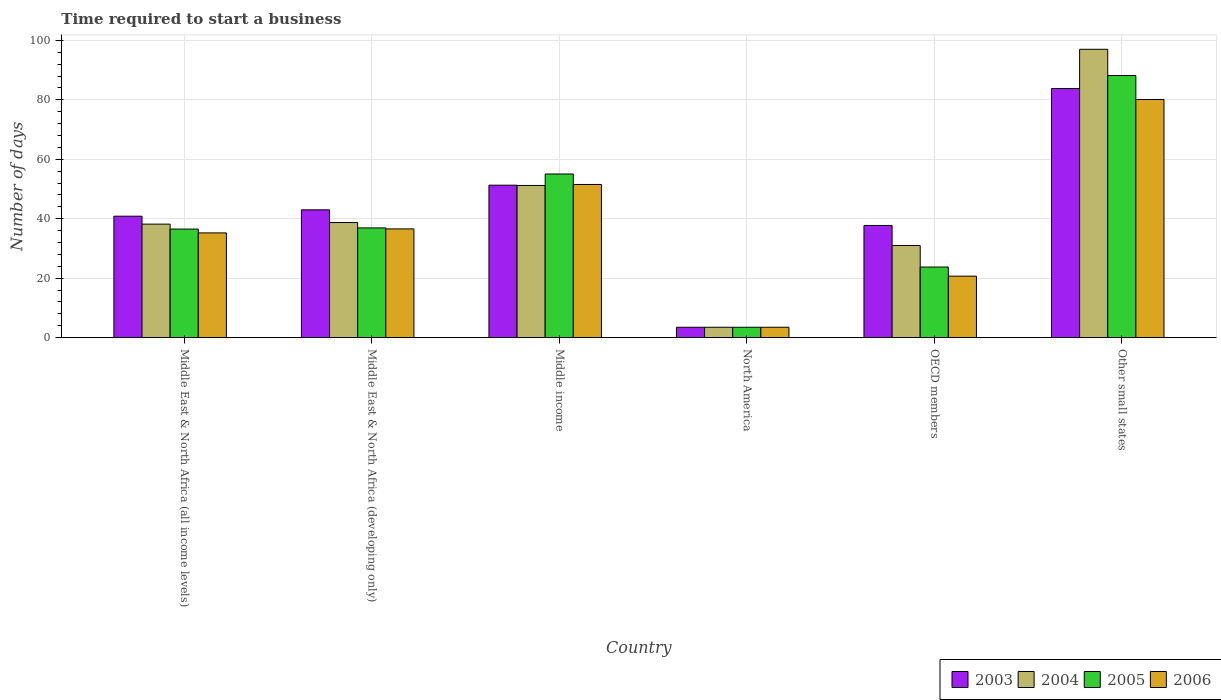How many different coloured bars are there?
Keep it short and to the point. 4. How many groups of bars are there?
Your response must be concise. 6. Are the number of bars per tick equal to the number of legend labels?
Offer a terse response. Yes. How many bars are there on the 4th tick from the left?
Offer a very short reply. 4. How many bars are there on the 3rd tick from the right?
Offer a very short reply. 4. What is the number of days required to start a business in 2004 in Middle East & North Africa (developing only)?
Give a very brief answer. 38.73. Across all countries, what is the maximum number of days required to start a business in 2003?
Keep it short and to the point. 83.8. In which country was the number of days required to start a business in 2005 maximum?
Offer a terse response. Other small states. What is the total number of days required to start a business in 2006 in the graph?
Offer a terse response. 227.65. What is the difference between the number of days required to start a business in 2005 in Middle East & North Africa (all income levels) and that in Middle East & North Africa (developing only)?
Offer a terse response. -0.39. What is the difference between the number of days required to start a business in 2006 in OECD members and the number of days required to start a business in 2003 in North America?
Keep it short and to the point. 17.19. What is the average number of days required to start a business in 2004 per country?
Provide a short and direct response. 43.27. What is the difference between the number of days required to start a business of/in 2006 and number of days required to start a business of/in 2005 in Middle East & North Africa (all income levels)?
Offer a terse response. -1.29. What is the ratio of the number of days required to start a business in 2003 in Middle East & North Africa (all income levels) to that in Middle income?
Make the answer very short. 0.8. Is the number of days required to start a business in 2003 in Middle East & North Africa (all income levels) less than that in Middle East & North Africa (developing only)?
Keep it short and to the point. Yes. What is the difference between the highest and the second highest number of days required to start a business in 2003?
Offer a very short reply. -32.51. What is the difference between the highest and the lowest number of days required to start a business in 2004?
Your answer should be compact. 93.5. In how many countries, is the number of days required to start a business in 2004 greater than the average number of days required to start a business in 2004 taken over all countries?
Make the answer very short. 2. Is it the case that in every country, the sum of the number of days required to start a business in 2006 and number of days required to start a business in 2004 is greater than the sum of number of days required to start a business in 2003 and number of days required to start a business in 2005?
Your answer should be very brief. No. What does the 3rd bar from the left in Middle East & North Africa (developing only) represents?
Offer a very short reply. 2005. What does the 2nd bar from the right in North America represents?
Make the answer very short. 2005. Are all the bars in the graph horizontal?
Offer a very short reply. No. How many countries are there in the graph?
Provide a short and direct response. 6. Where does the legend appear in the graph?
Offer a very short reply. Bottom right. What is the title of the graph?
Offer a terse response. Time required to start a business. Does "2014" appear as one of the legend labels in the graph?
Keep it short and to the point. No. What is the label or title of the Y-axis?
Your answer should be compact. Number of days. What is the Number of days of 2003 in Middle East & North Africa (all income levels)?
Your answer should be compact. 40.86. What is the Number of days of 2004 in Middle East & North Africa (all income levels)?
Your response must be concise. 38.19. What is the Number of days of 2005 in Middle East & North Africa (all income levels)?
Offer a terse response. 36.53. What is the Number of days of 2006 in Middle East & North Africa (all income levels)?
Make the answer very short. 35.24. What is the Number of days of 2004 in Middle East & North Africa (developing only)?
Ensure brevity in your answer.  38.73. What is the Number of days of 2005 in Middle East & North Africa (developing only)?
Offer a very short reply. 36.92. What is the Number of days in 2006 in Middle East & North Africa (developing only)?
Your answer should be compact. 36.58. What is the Number of days of 2003 in Middle income?
Keep it short and to the point. 51.29. What is the Number of days of 2004 in Middle income?
Ensure brevity in your answer.  51.19. What is the Number of days in 2005 in Middle income?
Provide a succinct answer. 55.06. What is the Number of days in 2006 in Middle income?
Your answer should be very brief. 51.53. What is the Number of days in 2003 in North America?
Your response must be concise. 3.5. What is the Number of days in 2005 in North America?
Make the answer very short. 3.5. What is the Number of days of 2003 in OECD members?
Your response must be concise. 37.74. What is the Number of days of 2004 in OECD members?
Make the answer very short. 31.02. What is the Number of days in 2005 in OECD members?
Ensure brevity in your answer.  23.75. What is the Number of days of 2006 in OECD members?
Ensure brevity in your answer.  20.69. What is the Number of days of 2003 in Other small states?
Your answer should be very brief. 83.8. What is the Number of days of 2004 in Other small states?
Your answer should be compact. 97. What is the Number of days in 2005 in Other small states?
Provide a short and direct response. 88.18. What is the Number of days of 2006 in Other small states?
Your answer should be very brief. 80.11. Across all countries, what is the maximum Number of days in 2003?
Provide a short and direct response. 83.8. Across all countries, what is the maximum Number of days of 2004?
Your response must be concise. 97. Across all countries, what is the maximum Number of days of 2005?
Offer a terse response. 88.18. Across all countries, what is the maximum Number of days of 2006?
Offer a terse response. 80.11. Across all countries, what is the minimum Number of days in 2004?
Provide a succinct answer. 3.5. What is the total Number of days in 2003 in the graph?
Provide a short and direct response. 260.18. What is the total Number of days of 2004 in the graph?
Make the answer very short. 259.63. What is the total Number of days in 2005 in the graph?
Your answer should be very brief. 243.93. What is the total Number of days in 2006 in the graph?
Your answer should be very brief. 227.65. What is the difference between the Number of days in 2003 in Middle East & North Africa (all income levels) and that in Middle East & North Africa (developing only)?
Provide a succinct answer. -2.14. What is the difference between the Number of days in 2004 in Middle East & North Africa (all income levels) and that in Middle East & North Africa (developing only)?
Offer a terse response. -0.54. What is the difference between the Number of days in 2005 in Middle East & North Africa (all income levels) and that in Middle East & North Africa (developing only)?
Your answer should be compact. -0.39. What is the difference between the Number of days of 2006 in Middle East & North Africa (all income levels) and that in Middle East & North Africa (developing only)?
Make the answer very short. -1.35. What is the difference between the Number of days of 2003 in Middle East & North Africa (all income levels) and that in Middle income?
Your answer should be very brief. -10.43. What is the difference between the Number of days in 2004 in Middle East & North Africa (all income levels) and that in Middle income?
Keep it short and to the point. -13.01. What is the difference between the Number of days of 2005 in Middle East & North Africa (all income levels) and that in Middle income?
Make the answer very short. -18.53. What is the difference between the Number of days in 2006 in Middle East & North Africa (all income levels) and that in Middle income?
Keep it short and to the point. -16.29. What is the difference between the Number of days of 2003 in Middle East & North Africa (all income levels) and that in North America?
Ensure brevity in your answer.  37.36. What is the difference between the Number of days in 2004 in Middle East & North Africa (all income levels) and that in North America?
Offer a terse response. 34.69. What is the difference between the Number of days in 2005 in Middle East & North Africa (all income levels) and that in North America?
Offer a terse response. 33.03. What is the difference between the Number of days of 2006 in Middle East & North Africa (all income levels) and that in North America?
Provide a short and direct response. 31.74. What is the difference between the Number of days in 2003 in Middle East & North Africa (all income levels) and that in OECD members?
Provide a succinct answer. 3.12. What is the difference between the Number of days of 2004 in Middle East & North Africa (all income levels) and that in OECD members?
Offer a terse response. 7.17. What is the difference between the Number of days in 2005 in Middle East & North Africa (all income levels) and that in OECD members?
Make the answer very short. 12.78. What is the difference between the Number of days in 2006 in Middle East & North Africa (all income levels) and that in OECD members?
Your answer should be very brief. 14.54. What is the difference between the Number of days in 2003 in Middle East & North Africa (all income levels) and that in Other small states?
Keep it short and to the point. -42.94. What is the difference between the Number of days of 2004 in Middle East & North Africa (all income levels) and that in Other small states?
Ensure brevity in your answer.  -58.81. What is the difference between the Number of days of 2005 in Middle East & North Africa (all income levels) and that in Other small states?
Provide a succinct answer. -51.65. What is the difference between the Number of days in 2006 in Middle East & North Africa (all income levels) and that in Other small states?
Provide a short and direct response. -44.88. What is the difference between the Number of days in 2003 in Middle East & North Africa (developing only) and that in Middle income?
Offer a terse response. -8.29. What is the difference between the Number of days in 2004 in Middle East & North Africa (developing only) and that in Middle income?
Ensure brevity in your answer.  -12.47. What is the difference between the Number of days of 2005 in Middle East & North Africa (developing only) and that in Middle income?
Offer a very short reply. -18.14. What is the difference between the Number of days of 2006 in Middle East & North Africa (developing only) and that in Middle income?
Your answer should be very brief. -14.94. What is the difference between the Number of days of 2003 in Middle East & North Africa (developing only) and that in North America?
Make the answer very short. 39.5. What is the difference between the Number of days in 2004 in Middle East & North Africa (developing only) and that in North America?
Offer a very short reply. 35.23. What is the difference between the Number of days of 2005 in Middle East & North Africa (developing only) and that in North America?
Keep it short and to the point. 33.42. What is the difference between the Number of days of 2006 in Middle East & North Africa (developing only) and that in North America?
Keep it short and to the point. 33.08. What is the difference between the Number of days in 2003 in Middle East & North Africa (developing only) and that in OECD members?
Provide a short and direct response. 5.26. What is the difference between the Number of days in 2004 in Middle East & North Africa (developing only) and that in OECD members?
Provide a succinct answer. 7.71. What is the difference between the Number of days of 2005 in Middle East & North Africa (developing only) and that in OECD members?
Offer a terse response. 13.17. What is the difference between the Number of days of 2006 in Middle East & North Africa (developing only) and that in OECD members?
Make the answer very short. 15.89. What is the difference between the Number of days in 2003 in Middle East & North Africa (developing only) and that in Other small states?
Provide a short and direct response. -40.8. What is the difference between the Number of days of 2004 in Middle East & North Africa (developing only) and that in Other small states?
Offer a terse response. -58.27. What is the difference between the Number of days of 2005 in Middle East & North Africa (developing only) and that in Other small states?
Offer a terse response. -51.26. What is the difference between the Number of days in 2006 in Middle East & North Africa (developing only) and that in Other small states?
Your answer should be very brief. -43.53. What is the difference between the Number of days in 2003 in Middle income and that in North America?
Your response must be concise. 47.79. What is the difference between the Number of days of 2004 in Middle income and that in North America?
Provide a short and direct response. 47.69. What is the difference between the Number of days of 2005 in Middle income and that in North America?
Provide a succinct answer. 51.56. What is the difference between the Number of days of 2006 in Middle income and that in North America?
Your answer should be very brief. 48.03. What is the difference between the Number of days of 2003 in Middle income and that in OECD members?
Ensure brevity in your answer.  13.54. What is the difference between the Number of days in 2004 in Middle income and that in OECD members?
Ensure brevity in your answer.  20.18. What is the difference between the Number of days of 2005 in Middle income and that in OECD members?
Provide a succinct answer. 31.31. What is the difference between the Number of days in 2006 in Middle income and that in OECD members?
Your answer should be compact. 30.83. What is the difference between the Number of days in 2003 in Middle income and that in Other small states?
Ensure brevity in your answer.  -32.51. What is the difference between the Number of days in 2004 in Middle income and that in Other small states?
Offer a very short reply. -45.81. What is the difference between the Number of days of 2005 in Middle income and that in Other small states?
Ensure brevity in your answer.  -33.12. What is the difference between the Number of days in 2006 in Middle income and that in Other small states?
Your answer should be compact. -28.58. What is the difference between the Number of days of 2003 in North America and that in OECD members?
Give a very brief answer. -34.24. What is the difference between the Number of days in 2004 in North America and that in OECD members?
Make the answer very short. -27.52. What is the difference between the Number of days in 2005 in North America and that in OECD members?
Your response must be concise. -20.25. What is the difference between the Number of days in 2006 in North America and that in OECD members?
Your answer should be compact. -17.19. What is the difference between the Number of days of 2003 in North America and that in Other small states?
Keep it short and to the point. -80.3. What is the difference between the Number of days of 2004 in North America and that in Other small states?
Provide a succinct answer. -93.5. What is the difference between the Number of days of 2005 in North America and that in Other small states?
Ensure brevity in your answer.  -84.68. What is the difference between the Number of days in 2006 in North America and that in Other small states?
Provide a succinct answer. -76.61. What is the difference between the Number of days in 2003 in OECD members and that in Other small states?
Offer a very short reply. -46.06. What is the difference between the Number of days of 2004 in OECD members and that in Other small states?
Provide a short and direct response. -65.98. What is the difference between the Number of days in 2005 in OECD members and that in Other small states?
Make the answer very short. -64.43. What is the difference between the Number of days in 2006 in OECD members and that in Other small states?
Give a very brief answer. -59.42. What is the difference between the Number of days of 2003 in Middle East & North Africa (all income levels) and the Number of days of 2004 in Middle East & North Africa (developing only)?
Keep it short and to the point. 2.13. What is the difference between the Number of days of 2003 in Middle East & North Africa (all income levels) and the Number of days of 2005 in Middle East & North Africa (developing only)?
Your response must be concise. 3.94. What is the difference between the Number of days in 2003 in Middle East & North Africa (all income levels) and the Number of days in 2006 in Middle East & North Africa (developing only)?
Ensure brevity in your answer.  4.27. What is the difference between the Number of days in 2004 in Middle East & North Africa (all income levels) and the Number of days in 2005 in Middle East & North Africa (developing only)?
Give a very brief answer. 1.27. What is the difference between the Number of days in 2004 in Middle East & North Africa (all income levels) and the Number of days in 2006 in Middle East & North Africa (developing only)?
Ensure brevity in your answer.  1.6. What is the difference between the Number of days of 2005 in Middle East & North Africa (all income levels) and the Number of days of 2006 in Middle East & North Africa (developing only)?
Provide a short and direct response. -0.05. What is the difference between the Number of days in 2003 in Middle East & North Africa (all income levels) and the Number of days in 2004 in Middle income?
Give a very brief answer. -10.34. What is the difference between the Number of days of 2003 in Middle East & North Africa (all income levels) and the Number of days of 2005 in Middle income?
Ensure brevity in your answer.  -14.2. What is the difference between the Number of days of 2003 in Middle East & North Africa (all income levels) and the Number of days of 2006 in Middle income?
Your response must be concise. -10.67. What is the difference between the Number of days of 2004 in Middle East & North Africa (all income levels) and the Number of days of 2005 in Middle income?
Provide a succinct answer. -16.87. What is the difference between the Number of days of 2004 in Middle East & North Africa (all income levels) and the Number of days of 2006 in Middle income?
Give a very brief answer. -13.34. What is the difference between the Number of days of 2005 in Middle East & North Africa (all income levels) and the Number of days of 2006 in Middle income?
Ensure brevity in your answer.  -15. What is the difference between the Number of days in 2003 in Middle East & North Africa (all income levels) and the Number of days in 2004 in North America?
Keep it short and to the point. 37.36. What is the difference between the Number of days of 2003 in Middle East & North Africa (all income levels) and the Number of days of 2005 in North America?
Provide a succinct answer. 37.36. What is the difference between the Number of days of 2003 in Middle East & North Africa (all income levels) and the Number of days of 2006 in North America?
Provide a succinct answer. 37.36. What is the difference between the Number of days in 2004 in Middle East & North Africa (all income levels) and the Number of days in 2005 in North America?
Make the answer very short. 34.69. What is the difference between the Number of days in 2004 in Middle East & North Africa (all income levels) and the Number of days in 2006 in North America?
Keep it short and to the point. 34.69. What is the difference between the Number of days of 2005 in Middle East & North Africa (all income levels) and the Number of days of 2006 in North America?
Your answer should be very brief. 33.03. What is the difference between the Number of days in 2003 in Middle East & North Africa (all income levels) and the Number of days in 2004 in OECD members?
Ensure brevity in your answer.  9.84. What is the difference between the Number of days in 2003 in Middle East & North Africa (all income levels) and the Number of days in 2005 in OECD members?
Offer a very short reply. 17.11. What is the difference between the Number of days in 2003 in Middle East & North Africa (all income levels) and the Number of days in 2006 in OECD members?
Offer a terse response. 20.16. What is the difference between the Number of days of 2004 in Middle East & North Africa (all income levels) and the Number of days of 2005 in OECD members?
Offer a terse response. 14.44. What is the difference between the Number of days of 2004 in Middle East & North Africa (all income levels) and the Number of days of 2006 in OECD members?
Your response must be concise. 17.49. What is the difference between the Number of days in 2005 in Middle East & North Africa (all income levels) and the Number of days in 2006 in OECD members?
Give a very brief answer. 15.84. What is the difference between the Number of days of 2003 in Middle East & North Africa (all income levels) and the Number of days of 2004 in Other small states?
Your answer should be compact. -56.14. What is the difference between the Number of days in 2003 in Middle East & North Africa (all income levels) and the Number of days in 2005 in Other small states?
Offer a very short reply. -47.32. What is the difference between the Number of days in 2003 in Middle East & North Africa (all income levels) and the Number of days in 2006 in Other small states?
Your answer should be compact. -39.25. What is the difference between the Number of days of 2004 in Middle East & North Africa (all income levels) and the Number of days of 2005 in Other small states?
Ensure brevity in your answer.  -49.99. What is the difference between the Number of days of 2004 in Middle East & North Africa (all income levels) and the Number of days of 2006 in Other small states?
Provide a short and direct response. -41.92. What is the difference between the Number of days of 2005 in Middle East & North Africa (all income levels) and the Number of days of 2006 in Other small states?
Your response must be concise. -43.58. What is the difference between the Number of days in 2003 in Middle East & North Africa (developing only) and the Number of days in 2004 in Middle income?
Your answer should be very brief. -8.19. What is the difference between the Number of days in 2003 in Middle East & North Africa (developing only) and the Number of days in 2005 in Middle income?
Offer a very short reply. -12.06. What is the difference between the Number of days in 2003 in Middle East & North Africa (developing only) and the Number of days in 2006 in Middle income?
Give a very brief answer. -8.53. What is the difference between the Number of days in 2004 in Middle East & North Africa (developing only) and the Number of days in 2005 in Middle income?
Your answer should be compact. -16.33. What is the difference between the Number of days of 2004 in Middle East & North Africa (developing only) and the Number of days of 2006 in Middle income?
Give a very brief answer. -12.8. What is the difference between the Number of days of 2005 in Middle East & North Africa (developing only) and the Number of days of 2006 in Middle income?
Give a very brief answer. -14.61. What is the difference between the Number of days of 2003 in Middle East & North Africa (developing only) and the Number of days of 2004 in North America?
Your response must be concise. 39.5. What is the difference between the Number of days in 2003 in Middle East & North Africa (developing only) and the Number of days in 2005 in North America?
Ensure brevity in your answer.  39.5. What is the difference between the Number of days of 2003 in Middle East & North Africa (developing only) and the Number of days of 2006 in North America?
Offer a terse response. 39.5. What is the difference between the Number of days in 2004 in Middle East & North Africa (developing only) and the Number of days in 2005 in North America?
Offer a terse response. 35.23. What is the difference between the Number of days of 2004 in Middle East & North Africa (developing only) and the Number of days of 2006 in North America?
Offer a terse response. 35.23. What is the difference between the Number of days of 2005 in Middle East & North Africa (developing only) and the Number of days of 2006 in North America?
Your answer should be very brief. 33.42. What is the difference between the Number of days of 2003 in Middle East & North Africa (developing only) and the Number of days of 2004 in OECD members?
Your response must be concise. 11.98. What is the difference between the Number of days in 2003 in Middle East & North Africa (developing only) and the Number of days in 2005 in OECD members?
Provide a short and direct response. 19.25. What is the difference between the Number of days of 2003 in Middle East & North Africa (developing only) and the Number of days of 2006 in OECD members?
Your response must be concise. 22.31. What is the difference between the Number of days in 2004 in Middle East & North Africa (developing only) and the Number of days in 2005 in OECD members?
Offer a terse response. 14.98. What is the difference between the Number of days in 2004 in Middle East & North Africa (developing only) and the Number of days in 2006 in OECD members?
Give a very brief answer. 18.03. What is the difference between the Number of days in 2005 in Middle East & North Africa (developing only) and the Number of days in 2006 in OECD members?
Offer a very short reply. 16.22. What is the difference between the Number of days in 2003 in Middle East & North Africa (developing only) and the Number of days in 2004 in Other small states?
Give a very brief answer. -54. What is the difference between the Number of days of 2003 in Middle East & North Africa (developing only) and the Number of days of 2005 in Other small states?
Your answer should be very brief. -45.18. What is the difference between the Number of days of 2003 in Middle East & North Africa (developing only) and the Number of days of 2006 in Other small states?
Offer a terse response. -37.11. What is the difference between the Number of days of 2004 in Middle East & North Africa (developing only) and the Number of days of 2005 in Other small states?
Your answer should be very brief. -49.45. What is the difference between the Number of days in 2004 in Middle East & North Africa (developing only) and the Number of days in 2006 in Other small states?
Offer a very short reply. -41.38. What is the difference between the Number of days in 2005 in Middle East & North Africa (developing only) and the Number of days in 2006 in Other small states?
Offer a terse response. -43.19. What is the difference between the Number of days of 2003 in Middle income and the Number of days of 2004 in North America?
Your answer should be compact. 47.79. What is the difference between the Number of days of 2003 in Middle income and the Number of days of 2005 in North America?
Your answer should be compact. 47.79. What is the difference between the Number of days of 2003 in Middle income and the Number of days of 2006 in North America?
Keep it short and to the point. 47.79. What is the difference between the Number of days in 2004 in Middle income and the Number of days in 2005 in North America?
Provide a short and direct response. 47.69. What is the difference between the Number of days in 2004 in Middle income and the Number of days in 2006 in North America?
Your response must be concise. 47.69. What is the difference between the Number of days of 2005 in Middle income and the Number of days of 2006 in North America?
Provide a succinct answer. 51.56. What is the difference between the Number of days in 2003 in Middle income and the Number of days in 2004 in OECD members?
Make the answer very short. 20.27. What is the difference between the Number of days in 2003 in Middle income and the Number of days in 2005 in OECD members?
Provide a succinct answer. 27.54. What is the difference between the Number of days in 2003 in Middle income and the Number of days in 2006 in OECD members?
Your answer should be compact. 30.59. What is the difference between the Number of days in 2004 in Middle income and the Number of days in 2005 in OECD members?
Your response must be concise. 27.44. What is the difference between the Number of days in 2004 in Middle income and the Number of days in 2006 in OECD members?
Ensure brevity in your answer.  30.5. What is the difference between the Number of days in 2005 in Middle income and the Number of days in 2006 in OECD members?
Provide a succinct answer. 34.36. What is the difference between the Number of days in 2003 in Middle income and the Number of days in 2004 in Other small states?
Give a very brief answer. -45.71. What is the difference between the Number of days of 2003 in Middle income and the Number of days of 2005 in Other small states?
Your answer should be very brief. -36.89. What is the difference between the Number of days of 2003 in Middle income and the Number of days of 2006 in Other small states?
Offer a terse response. -28.83. What is the difference between the Number of days of 2004 in Middle income and the Number of days of 2005 in Other small states?
Your answer should be very brief. -36.98. What is the difference between the Number of days of 2004 in Middle income and the Number of days of 2006 in Other small states?
Provide a short and direct response. -28.92. What is the difference between the Number of days in 2005 in Middle income and the Number of days in 2006 in Other small states?
Your response must be concise. -25.05. What is the difference between the Number of days of 2003 in North America and the Number of days of 2004 in OECD members?
Offer a very short reply. -27.52. What is the difference between the Number of days in 2003 in North America and the Number of days in 2005 in OECD members?
Your response must be concise. -20.25. What is the difference between the Number of days of 2003 in North America and the Number of days of 2006 in OECD members?
Give a very brief answer. -17.19. What is the difference between the Number of days of 2004 in North America and the Number of days of 2005 in OECD members?
Ensure brevity in your answer.  -20.25. What is the difference between the Number of days in 2004 in North America and the Number of days in 2006 in OECD members?
Ensure brevity in your answer.  -17.19. What is the difference between the Number of days of 2005 in North America and the Number of days of 2006 in OECD members?
Offer a very short reply. -17.19. What is the difference between the Number of days of 2003 in North America and the Number of days of 2004 in Other small states?
Make the answer very short. -93.5. What is the difference between the Number of days of 2003 in North America and the Number of days of 2005 in Other small states?
Your answer should be very brief. -84.68. What is the difference between the Number of days of 2003 in North America and the Number of days of 2006 in Other small states?
Offer a very short reply. -76.61. What is the difference between the Number of days of 2004 in North America and the Number of days of 2005 in Other small states?
Provide a succinct answer. -84.68. What is the difference between the Number of days of 2004 in North America and the Number of days of 2006 in Other small states?
Provide a succinct answer. -76.61. What is the difference between the Number of days in 2005 in North America and the Number of days in 2006 in Other small states?
Your answer should be compact. -76.61. What is the difference between the Number of days of 2003 in OECD members and the Number of days of 2004 in Other small states?
Offer a very short reply. -59.26. What is the difference between the Number of days in 2003 in OECD members and the Number of days in 2005 in Other small states?
Give a very brief answer. -50.44. What is the difference between the Number of days of 2003 in OECD members and the Number of days of 2006 in Other small states?
Provide a short and direct response. -42.37. What is the difference between the Number of days in 2004 in OECD members and the Number of days in 2005 in Other small states?
Ensure brevity in your answer.  -57.16. What is the difference between the Number of days of 2004 in OECD members and the Number of days of 2006 in Other small states?
Offer a very short reply. -49.09. What is the difference between the Number of days of 2005 in OECD members and the Number of days of 2006 in Other small states?
Your answer should be compact. -56.36. What is the average Number of days in 2003 per country?
Your answer should be very brief. 43.36. What is the average Number of days of 2004 per country?
Provide a short and direct response. 43.27. What is the average Number of days in 2005 per country?
Provide a short and direct response. 40.65. What is the average Number of days of 2006 per country?
Offer a very short reply. 37.94. What is the difference between the Number of days in 2003 and Number of days in 2004 in Middle East & North Africa (all income levels)?
Provide a short and direct response. 2.67. What is the difference between the Number of days in 2003 and Number of days in 2005 in Middle East & North Africa (all income levels)?
Your answer should be compact. 4.33. What is the difference between the Number of days in 2003 and Number of days in 2006 in Middle East & North Africa (all income levels)?
Offer a terse response. 5.62. What is the difference between the Number of days in 2004 and Number of days in 2005 in Middle East & North Africa (all income levels)?
Your answer should be very brief. 1.66. What is the difference between the Number of days in 2004 and Number of days in 2006 in Middle East & North Africa (all income levels)?
Your answer should be compact. 2.95. What is the difference between the Number of days of 2005 and Number of days of 2006 in Middle East & North Africa (all income levels)?
Offer a terse response. 1.29. What is the difference between the Number of days of 2003 and Number of days of 2004 in Middle East & North Africa (developing only)?
Your answer should be very brief. 4.27. What is the difference between the Number of days of 2003 and Number of days of 2005 in Middle East & North Africa (developing only)?
Give a very brief answer. 6.08. What is the difference between the Number of days in 2003 and Number of days in 2006 in Middle East & North Africa (developing only)?
Offer a terse response. 6.42. What is the difference between the Number of days of 2004 and Number of days of 2005 in Middle East & North Africa (developing only)?
Your answer should be compact. 1.81. What is the difference between the Number of days in 2004 and Number of days in 2006 in Middle East & North Africa (developing only)?
Your answer should be compact. 2.14. What is the difference between the Number of days of 2003 and Number of days of 2004 in Middle income?
Provide a succinct answer. 0.09. What is the difference between the Number of days of 2003 and Number of days of 2005 in Middle income?
Your response must be concise. -3.77. What is the difference between the Number of days of 2003 and Number of days of 2006 in Middle income?
Your answer should be compact. -0.24. What is the difference between the Number of days in 2004 and Number of days in 2005 in Middle income?
Offer a very short reply. -3.86. What is the difference between the Number of days in 2004 and Number of days in 2006 in Middle income?
Provide a short and direct response. -0.33. What is the difference between the Number of days in 2005 and Number of days in 2006 in Middle income?
Provide a succinct answer. 3.53. What is the difference between the Number of days in 2003 and Number of days in 2004 in North America?
Your answer should be compact. 0. What is the difference between the Number of days in 2003 and Number of days in 2006 in North America?
Keep it short and to the point. 0. What is the difference between the Number of days of 2004 and Number of days of 2005 in North America?
Give a very brief answer. 0. What is the difference between the Number of days in 2005 and Number of days in 2006 in North America?
Make the answer very short. 0. What is the difference between the Number of days in 2003 and Number of days in 2004 in OECD members?
Your answer should be very brief. 6.72. What is the difference between the Number of days of 2003 and Number of days of 2005 in OECD members?
Your response must be concise. 13.99. What is the difference between the Number of days of 2003 and Number of days of 2006 in OECD members?
Provide a short and direct response. 17.05. What is the difference between the Number of days in 2004 and Number of days in 2005 in OECD members?
Keep it short and to the point. 7.27. What is the difference between the Number of days of 2004 and Number of days of 2006 in OECD members?
Your response must be concise. 10.32. What is the difference between the Number of days of 2005 and Number of days of 2006 in OECD members?
Ensure brevity in your answer.  3.06. What is the difference between the Number of days in 2003 and Number of days in 2005 in Other small states?
Offer a very short reply. -4.38. What is the difference between the Number of days of 2003 and Number of days of 2006 in Other small states?
Your answer should be very brief. 3.69. What is the difference between the Number of days of 2004 and Number of days of 2005 in Other small states?
Make the answer very short. 8.82. What is the difference between the Number of days in 2004 and Number of days in 2006 in Other small states?
Make the answer very short. 16.89. What is the difference between the Number of days of 2005 and Number of days of 2006 in Other small states?
Offer a very short reply. 8.07. What is the ratio of the Number of days in 2003 in Middle East & North Africa (all income levels) to that in Middle East & North Africa (developing only)?
Offer a terse response. 0.95. What is the ratio of the Number of days of 2004 in Middle East & North Africa (all income levels) to that in Middle East & North Africa (developing only)?
Your answer should be very brief. 0.99. What is the ratio of the Number of days in 2005 in Middle East & North Africa (all income levels) to that in Middle East & North Africa (developing only)?
Provide a succinct answer. 0.99. What is the ratio of the Number of days of 2006 in Middle East & North Africa (all income levels) to that in Middle East & North Africa (developing only)?
Ensure brevity in your answer.  0.96. What is the ratio of the Number of days of 2003 in Middle East & North Africa (all income levels) to that in Middle income?
Ensure brevity in your answer.  0.8. What is the ratio of the Number of days in 2004 in Middle East & North Africa (all income levels) to that in Middle income?
Your answer should be very brief. 0.75. What is the ratio of the Number of days in 2005 in Middle East & North Africa (all income levels) to that in Middle income?
Your response must be concise. 0.66. What is the ratio of the Number of days in 2006 in Middle East & North Africa (all income levels) to that in Middle income?
Provide a succinct answer. 0.68. What is the ratio of the Number of days of 2003 in Middle East & North Africa (all income levels) to that in North America?
Give a very brief answer. 11.67. What is the ratio of the Number of days in 2004 in Middle East & North Africa (all income levels) to that in North America?
Ensure brevity in your answer.  10.91. What is the ratio of the Number of days of 2005 in Middle East & North Africa (all income levels) to that in North America?
Your response must be concise. 10.44. What is the ratio of the Number of days of 2006 in Middle East & North Africa (all income levels) to that in North America?
Offer a very short reply. 10.07. What is the ratio of the Number of days in 2003 in Middle East & North Africa (all income levels) to that in OECD members?
Offer a very short reply. 1.08. What is the ratio of the Number of days of 2004 in Middle East & North Africa (all income levels) to that in OECD members?
Make the answer very short. 1.23. What is the ratio of the Number of days in 2005 in Middle East & North Africa (all income levels) to that in OECD members?
Ensure brevity in your answer.  1.54. What is the ratio of the Number of days of 2006 in Middle East & North Africa (all income levels) to that in OECD members?
Keep it short and to the point. 1.7. What is the ratio of the Number of days of 2003 in Middle East & North Africa (all income levels) to that in Other small states?
Give a very brief answer. 0.49. What is the ratio of the Number of days of 2004 in Middle East & North Africa (all income levels) to that in Other small states?
Your answer should be compact. 0.39. What is the ratio of the Number of days of 2005 in Middle East & North Africa (all income levels) to that in Other small states?
Make the answer very short. 0.41. What is the ratio of the Number of days of 2006 in Middle East & North Africa (all income levels) to that in Other small states?
Ensure brevity in your answer.  0.44. What is the ratio of the Number of days of 2003 in Middle East & North Africa (developing only) to that in Middle income?
Keep it short and to the point. 0.84. What is the ratio of the Number of days in 2004 in Middle East & North Africa (developing only) to that in Middle income?
Provide a short and direct response. 0.76. What is the ratio of the Number of days of 2005 in Middle East & North Africa (developing only) to that in Middle income?
Offer a terse response. 0.67. What is the ratio of the Number of days of 2006 in Middle East & North Africa (developing only) to that in Middle income?
Give a very brief answer. 0.71. What is the ratio of the Number of days of 2003 in Middle East & North Africa (developing only) to that in North America?
Your answer should be very brief. 12.29. What is the ratio of the Number of days in 2004 in Middle East & North Africa (developing only) to that in North America?
Ensure brevity in your answer.  11.06. What is the ratio of the Number of days of 2005 in Middle East & North Africa (developing only) to that in North America?
Provide a succinct answer. 10.55. What is the ratio of the Number of days in 2006 in Middle East & North Africa (developing only) to that in North America?
Make the answer very short. 10.45. What is the ratio of the Number of days in 2003 in Middle East & North Africa (developing only) to that in OECD members?
Your answer should be very brief. 1.14. What is the ratio of the Number of days in 2004 in Middle East & North Africa (developing only) to that in OECD members?
Ensure brevity in your answer.  1.25. What is the ratio of the Number of days of 2005 in Middle East & North Africa (developing only) to that in OECD members?
Provide a short and direct response. 1.55. What is the ratio of the Number of days of 2006 in Middle East & North Africa (developing only) to that in OECD members?
Your response must be concise. 1.77. What is the ratio of the Number of days in 2003 in Middle East & North Africa (developing only) to that in Other small states?
Your response must be concise. 0.51. What is the ratio of the Number of days of 2004 in Middle East & North Africa (developing only) to that in Other small states?
Offer a very short reply. 0.4. What is the ratio of the Number of days of 2005 in Middle East & North Africa (developing only) to that in Other small states?
Give a very brief answer. 0.42. What is the ratio of the Number of days of 2006 in Middle East & North Africa (developing only) to that in Other small states?
Make the answer very short. 0.46. What is the ratio of the Number of days in 2003 in Middle income to that in North America?
Give a very brief answer. 14.65. What is the ratio of the Number of days of 2004 in Middle income to that in North America?
Make the answer very short. 14.63. What is the ratio of the Number of days in 2005 in Middle income to that in North America?
Your answer should be very brief. 15.73. What is the ratio of the Number of days in 2006 in Middle income to that in North America?
Offer a terse response. 14.72. What is the ratio of the Number of days of 2003 in Middle income to that in OECD members?
Give a very brief answer. 1.36. What is the ratio of the Number of days in 2004 in Middle income to that in OECD members?
Provide a succinct answer. 1.65. What is the ratio of the Number of days of 2005 in Middle income to that in OECD members?
Give a very brief answer. 2.32. What is the ratio of the Number of days in 2006 in Middle income to that in OECD members?
Provide a short and direct response. 2.49. What is the ratio of the Number of days in 2003 in Middle income to that in Other small states?
Offer a very short reply. 0.61. What is the ratio of the Number of days in 2004 in Middle income to that in Other small states?
Make the answer very short. 0.53. What is the ratio of the Number of days in 2005 in Middle income to that in Other small states?
Your response must be concise. 0.62. What is the ratio of the Number of days of 2006 in Middle income to that in Other small states?
Your answer should be compact. 0.64. What is the ratio of the Number of days in 2003 in North America to that in OECD members?
Make the answer very short. 0.09. What is the ratio of the Number of days in 2004 in North America to that in OECD members?
Offer a very short reply. 0.11. What is the ratio of the Number of days of 2005 in North America to that in OECD members?
Ensure brevity in your answer.  0.15. What is the ratio of the Number of days of 2006 in North America to that in OECD members?
Your response must be concise. 0.17. What is the ratio of the Number of days in 2003 in North America to that in Other small states?
Offer a very short reply. 0.04. What is the ratio of the Number of days in 2004 in North America to that in Other small states?
Give a very brief answer. 0.04. What is the ratio of the Number of days of 2005 in North America to that in Other small states?
Your answer should be very brief. 0.04. What is the ratio of the Number of days in 2006 in North America to that in Other small states?
Offer a very short reply. 0.04. What is the ratio of the Number of days in 2003 in OECD members to that in Other small states?
Give a very brief answer. 0.45. What is the ratio of the Number of days in 2004 in OECD members to that in Other small states?
Your answer should be very brief. 0.32. What is the ratio of the Number of days in 2005 in OECD members to that in Other small states?
Your answer should be very brief. 0.27. What is the ratio of the Number of days of 2006 in OECD members to that in Other small states?
Provide a succinct answer. 0.26. What is the difference between the highest and the second highest Number of days in 2003?
Provide a succinct answer. 32.51. What is the difference between the highest and the second highest Number of days of 2004?
Give a very brief answer. 45.81. What is the difference between the highest and the second highest Number of days of 2005?
Your answer should be very brief. 33.12. What is the difference between the highest and the second highest Number of days in 2006?
Give a very brief answer. 28.58. What is the difference between the highest and the lowest Number of days in 2003?
Ensure brevity in your answer.  80.3. What is the difference between the highest and the lowest Number of days of 2004?
Offer a terse response. 93.5. What is the difference between the highest and the lowest Number of days of 2005?
Make the answer very short. 84.68. What is the difference between the highest and the lowest Number of days in 2006?
Your answer should be very brief. 76.61. 